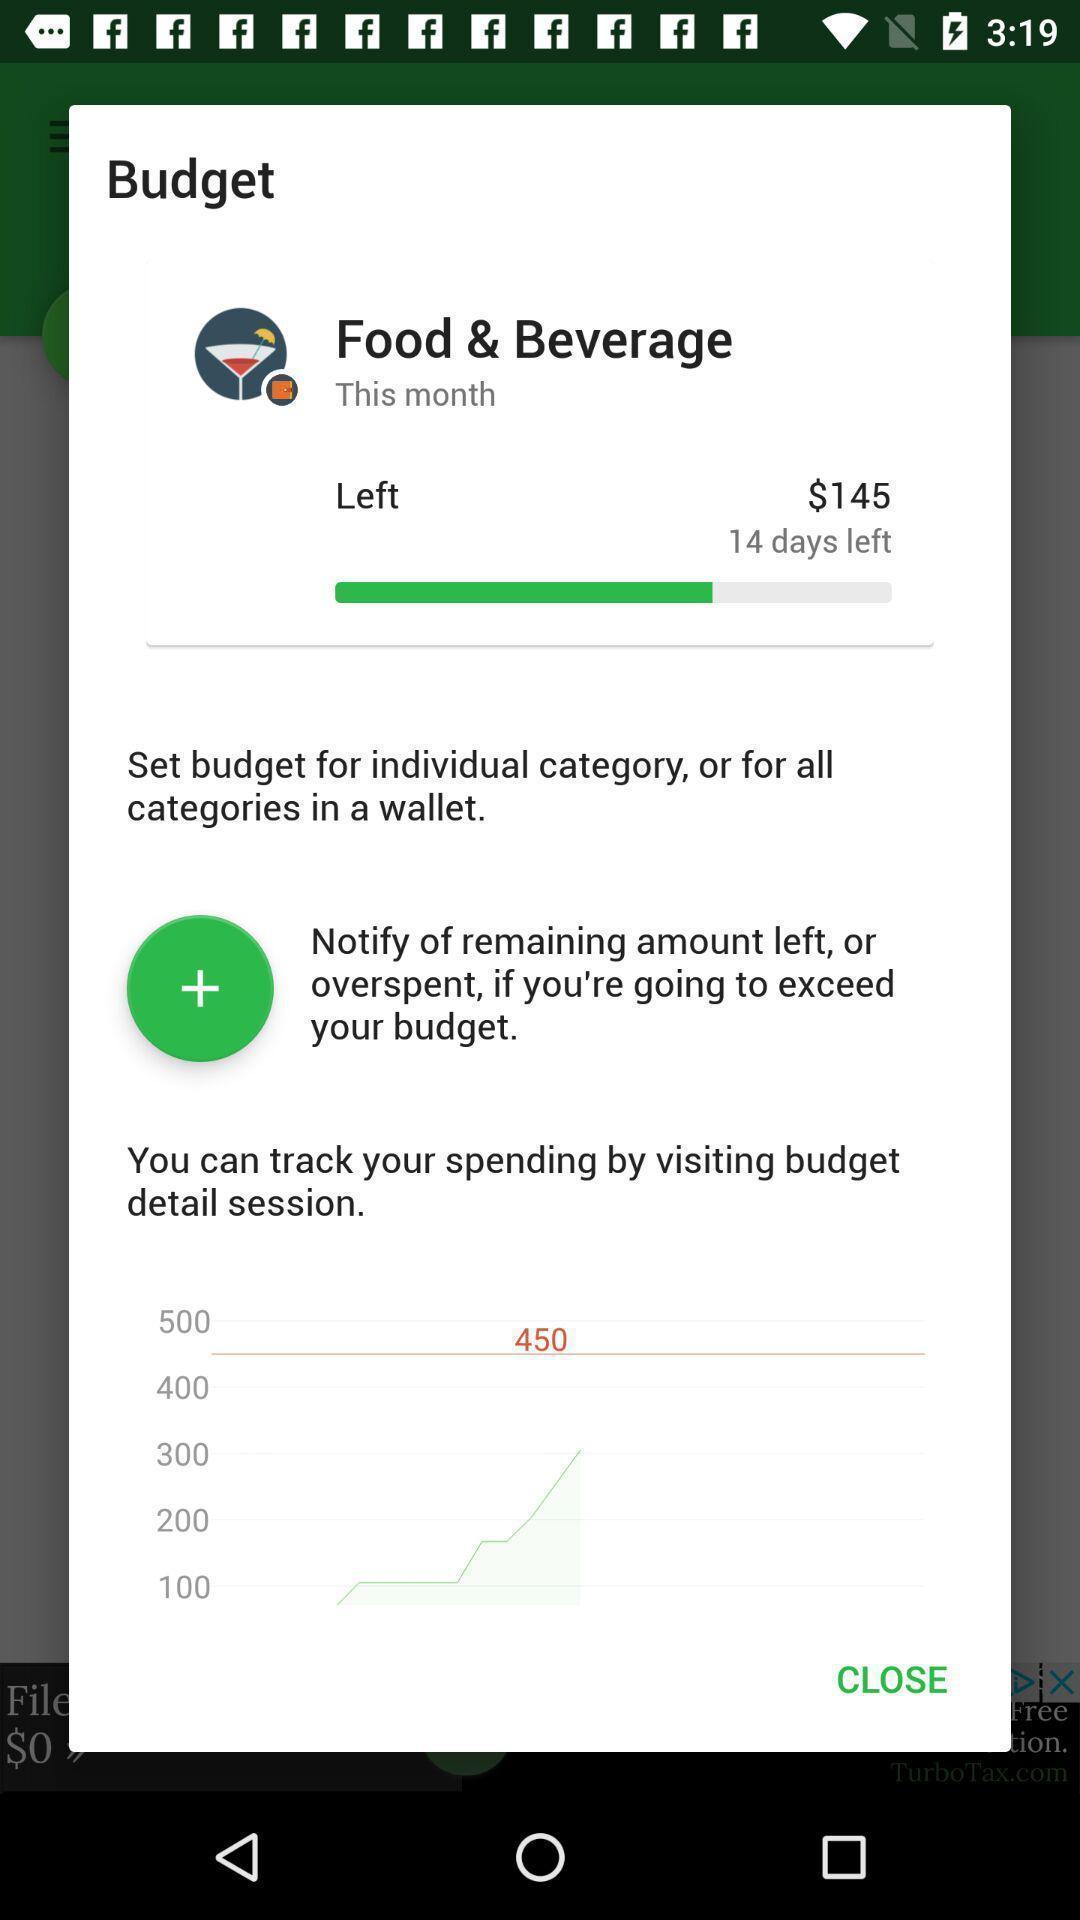What can you discern from this picture? Pop-up displaying the budget page. 